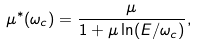<formula> <loc_0><loc_0><loc_500><loc_500>\mu ^ { \ast } ( \omega _ { c } ) = \frac { \mu } { 1 + \mu \ln ( E / \omega _ { c } ) } ,</formula> 